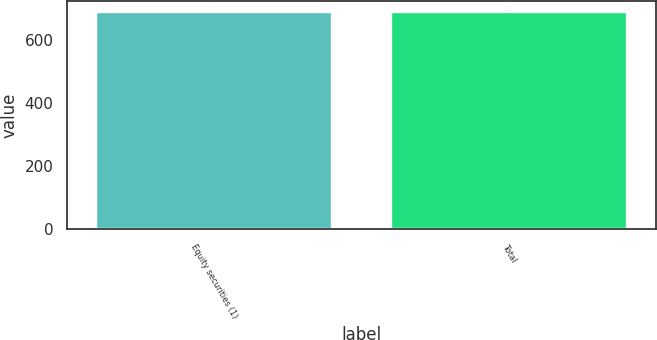Convert chart. <chart><loc_0><loc_0><loc_500><loc_500><bar_chart><fcel>Equity securities (1)<fcel>Total<nl><fcel>691.5<fcel>691.6<nl></chart> 